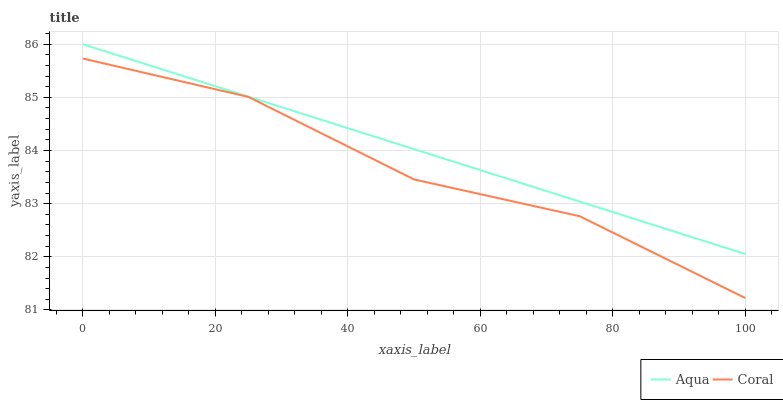Does Coral have the minimum area under the curve?
Answer yes or no. Yes. Does Aqua have the maximum area under the curve?
Answer yes or no. Yes. Does Aqua have the minimum area under the curve?
Answer yes or no. No. Is Aqua the smoothest?
Answer yes or no. Yes. Is Coral the roughest?
Answer yes or no. Yes. Is Aqua the roughest?
Answer yes or no. No. Does Coral have the lowest value?
Answer yes or no. Yes. Does Aqua have the lowest value?
Answer yes or no. No. Does Aqua have the highest value?
Answer yes or no. Yes. Is Coral less than Aqua?
Answer yes or no. Yes. Is Aqua greater than Coral?
Answer yes or no. Yes. Does Coral intersect Aqua?
Answer yes or no. No. 